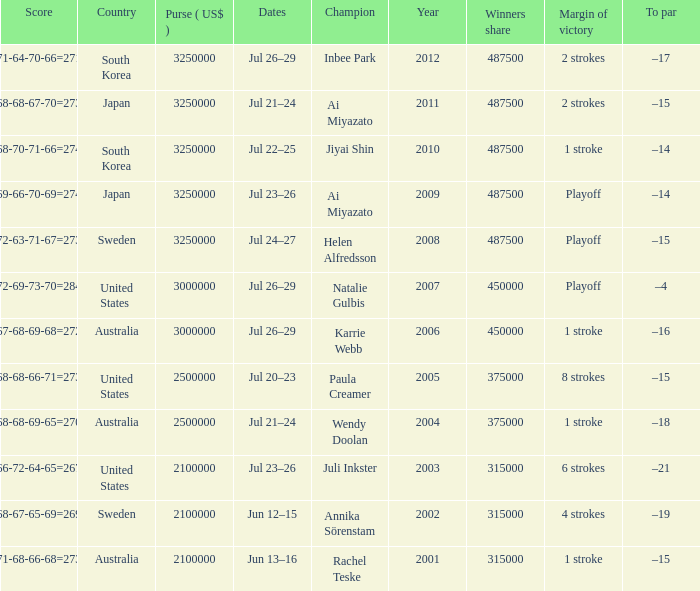What is the lowest year listed? 2001.0. 